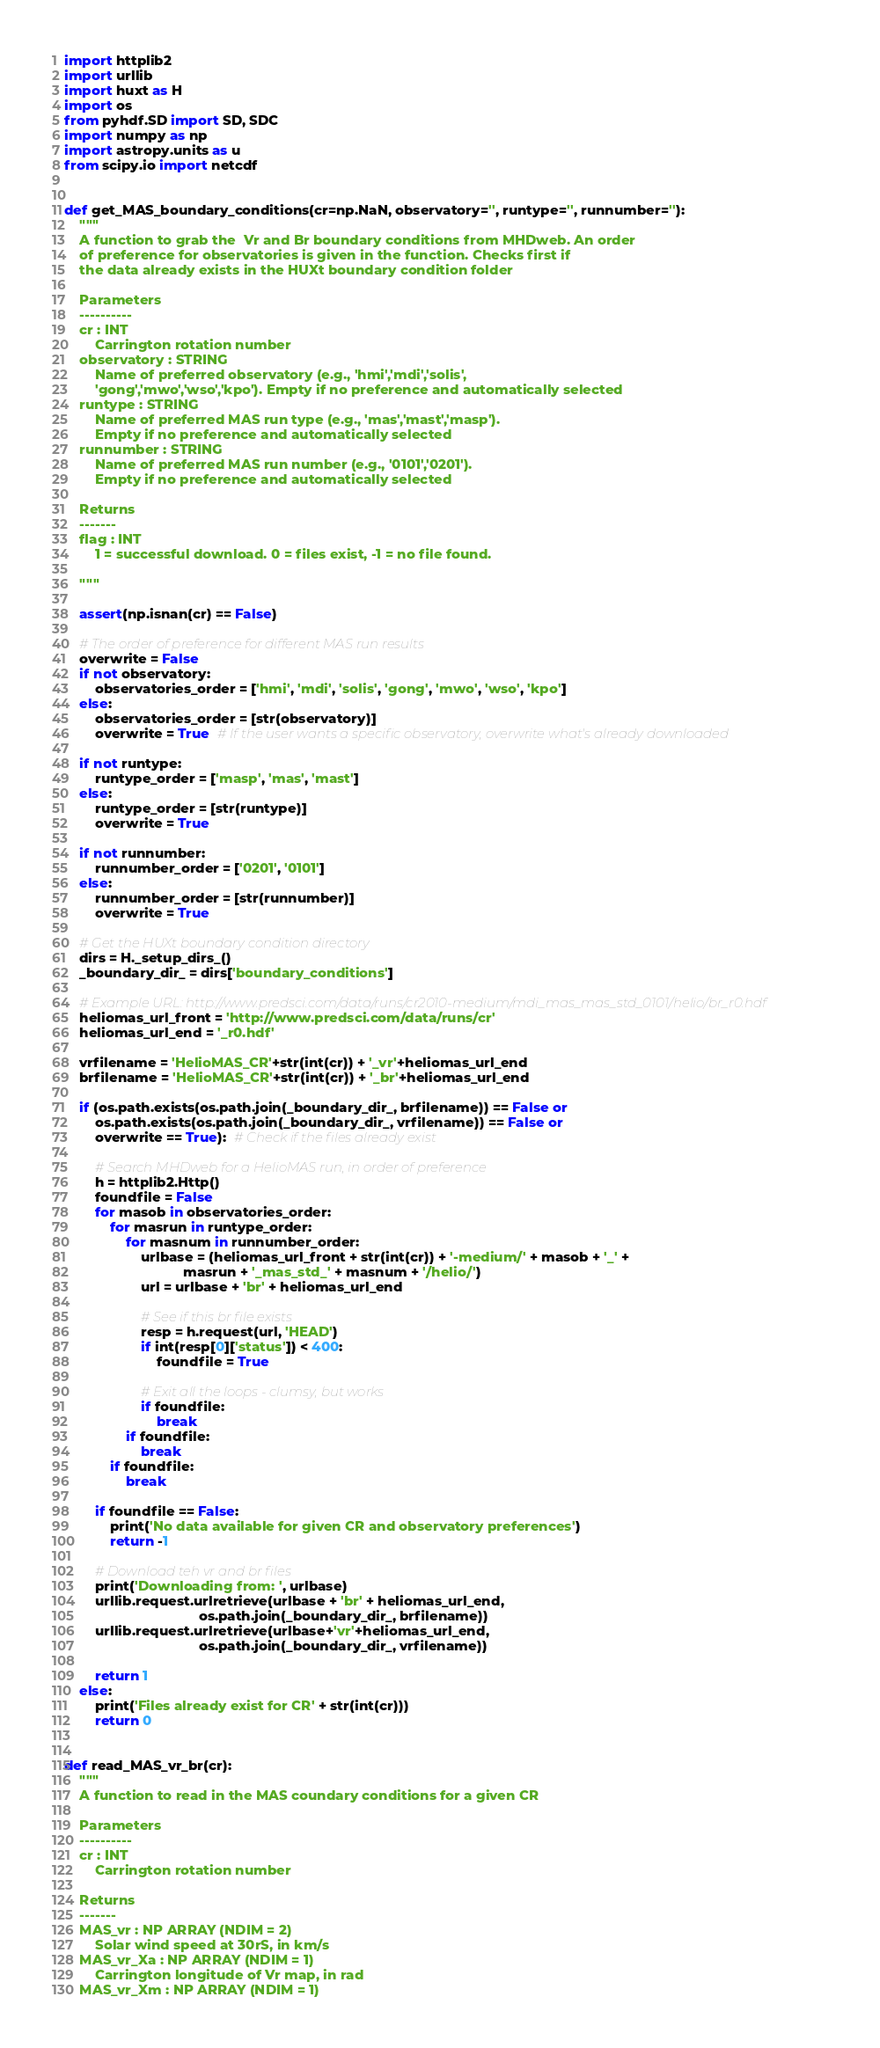Convert code to text. <code><loc_0><loc_0><loc_500><loc_500><_Python_>import httplib2
import urllib
import huxt as H
import os
from pyhdf.SD import SD, SDC  
import numpy as np
import astropy.units as u
from scipy.io import netcdf


def get_MAS_boundary_conditions(cr=np.NaN, observatory='', runtype='', runnumber=''):
    """
    A function to grab the  Vr and Br boundary conditions from MHDweb. An order
    of preference for observatories is given in the function. Checks first if
    the data already exists in the HUXt boundary condition folder

    Parameters
    ----------
    cr : INT
        Carrington rotation number 
    observatory : STRING
        Name of preferred observatory (e.g., 'hmi','mdi','solis',
        'gong','mwo','wso','kpo'). Empty if no preference and automatically selected 
    runtype : STRING
        Name of preferred MAS run type (e.g., 'mas','mast','masp').
        Empty if no preference and automatically selected 
    runnumber : STRING
        Name of preferred MAS run number (e.g., '0101','0201').
        Empty if no preference and automatically selected    

    Returns
    -------
    flag : INT
        1 = successful download. 0 = files exist, -1 = no file found.

    """
    
    assert(np.isnan(cr) == False)
    
    # The order of preference for different MAS run results
    overwrite = False
    if not observatory:
        observatories_order = ['hmi', 'mdi', 'solis', 'gong', 'mwo', 'wso', 'kpo']
    else:
        observatories_order = [str(observatory)]
        overwrite = True  # If the user wants a specific observatory, overwrite what's already downloaded
        
    if not runtype:
        runtype_order = ['masp', 'mas', 'mast']
    else:
        runtype_order = [str(runtype)]
        overwrite = True
    
    if not runnumber:
        runnumber_order = ['0201', '0101']
    else:
        runnumber_order = [str(runnumber)]
        overwrite = True
    
    # Get the HUXt boundary condition directory
    dirs = H._setup_dirs_()
    _boundary_dir_ = dirs['boundary_conditions'] 
      
    # Example URL: http://www.predsci.com/data/runs/cr2010-medium/mdi_mas_mas_std_0101/helio/br_r0.hdf
    heliomas_url_front = 'http://www.predsci.com/data/runs/cr'
    heliomas_url_end = '_r0.hdf'
    
    vrfilename = 'HelioMAS_CR'+str(int(cr)) + '_vr'+heliomas_url_end
    brfilename = 'HelioMAS_CR'+str(int(cr)) + '_br'+heliomas_url_end
    
    if (os.path.exists(os.path.join(_boundary_dir_, brfilename)) == False or
        os.path.exists(os.path.join(_boundary_dir_, vrfilename)) == False or
        overwrite == True):  # Check if the files already exist

        # Search MHDweb for a HelioMAS run, in order of preference
        h = httplib2.Http()
        foundfile = False
        for masob in observatories_order:
            for masrun in runtype_order:
                for masnum in runnumber_order:
                    urlbase = (heliomas_url_front + str(int(cr)) + '-medium/' + masob + '_' +
                               masrun + '_mas_std_' + masnum + '/helio/')
                    url = urlbase + 'br' + heliomas_url_end

                    # See if this br file exists
                    resp = h.request(url, 'HEAD')
                    if int(resp[0]['status']) < 400:
                        foundfile = True
                                            
                    # Exit all the loops - clumsy, but works
                    if foundfile: 
                        break
                if foundfile:
                    break
            if foundfile:
                break
            
        if foundfile == False:
            print('No data available for given CR and observatory preferences')
            return -1
        
        # Download teh vr and br files
        print('Downloading from: ', urlbase)
        urllib.request.urlretrieve(urlbase + 'br' + heliomas_url_end,
                                   os.path.join(_boundary_dir_, brfilename))
        urllib.request.urlretrieve(urlbase+'vr'+heliomas_url_end,
                                   os.path.join(_boundary_dir_, vrfilename))
        
        return 1
    else:
        print('Files already exist for CR' + str(int(cr)))
        return 0

    
def read_MAS_vr_br(cr):
    """
    A function to read in the MAS coundary conditions for a given CR

    Parameters
    ----------
    cr : INT
        Carrington rotation number

    Returns
    -------
    MAS_vr : NP ARRAY (NDIM = 2)
        Solar wind speed at 30rS, in km/s
    MAS_vr_Xa : NP ARRAY (NDIM = 1)
        Carrington longitude of Vr map, in rad
    MAS_vr_Xm : NP ARRAY (NDIM = 1)</code> 